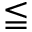Convert formula to latex. <formula><loc_0><loc_0><loc_500><loc_500>\leqq</formula> 